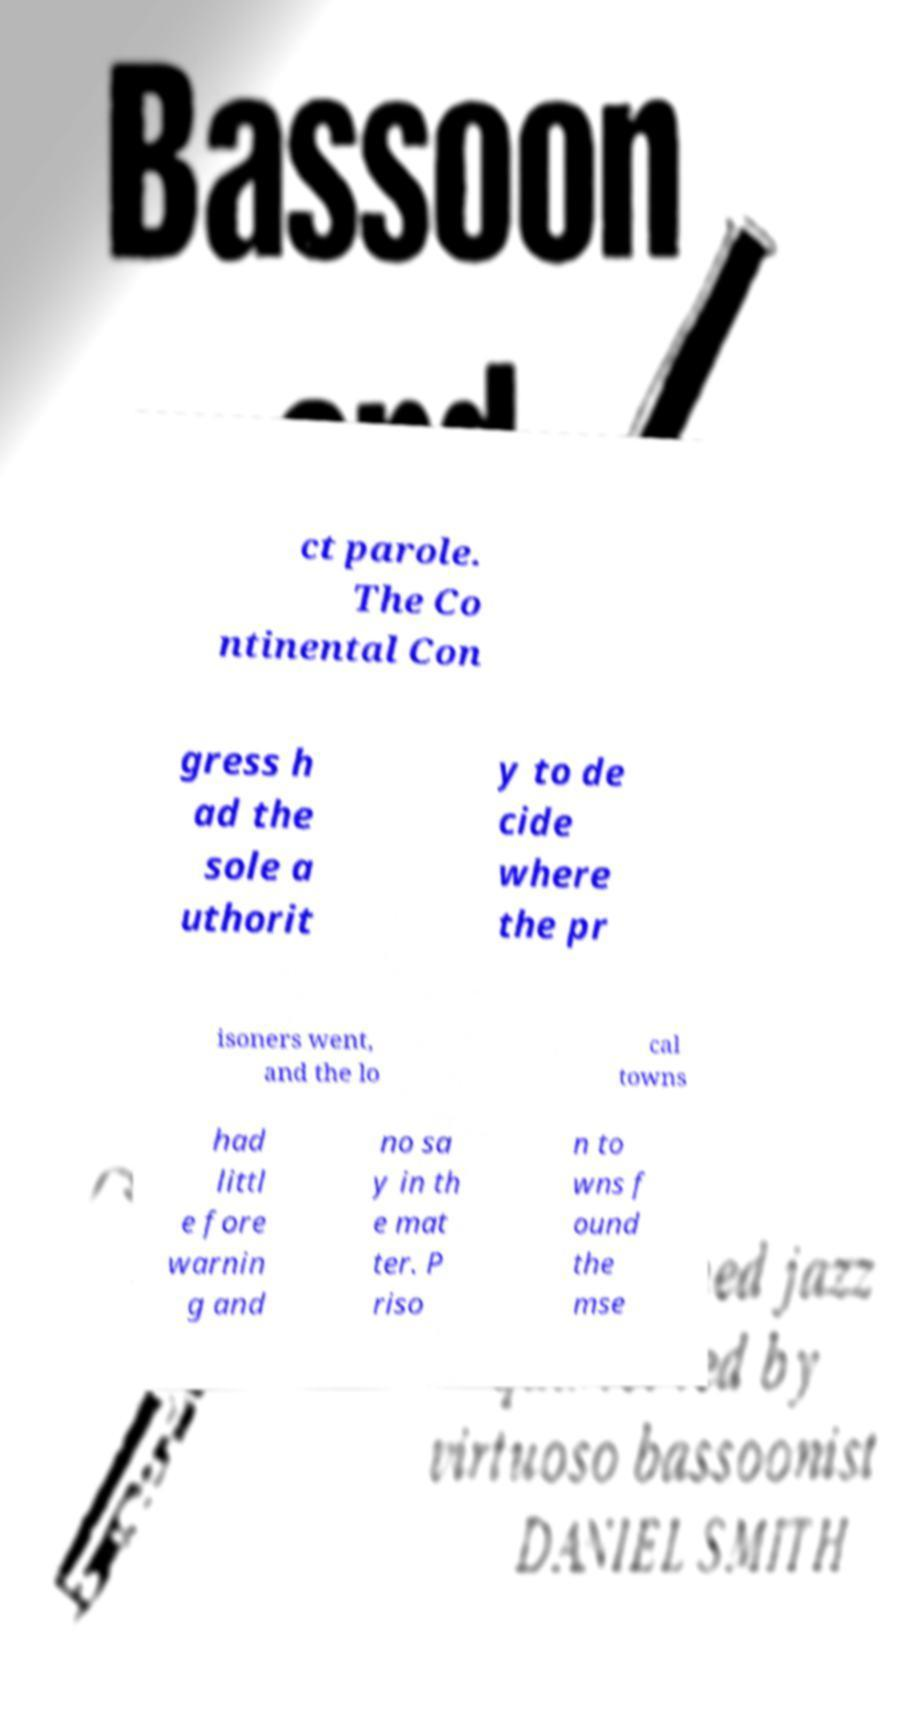There's text embedded in this image that I need extracted. Can you transcribe it verbatim? ct parole. The Co ntinental Con gress h ad the sole a uthorit y to de cide where the pr isoners went, and the lo cal towns had littl e fore warnin g and no sa y in th e mat ter. P riso n to wns f ound the mse 